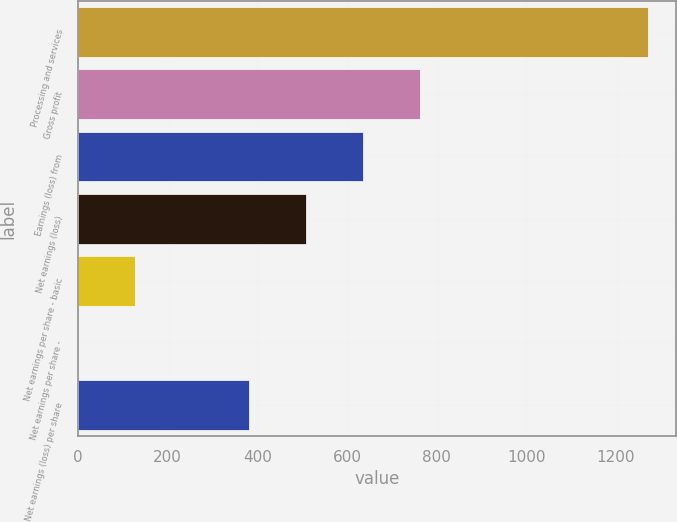Convert chart. <chart><loc_0><loc_0><loc_500><loc_500><bar_chart><fcel>Processing and services<fcel>Gross profit<fcel>Earnings (loss) from<fcel>Net earnings (loss)<fcel>Net earnings per share - basic<fcel>Net earnings per share -<fcel>Net earnings (loss) per share<nl><fcel>1271<fcel>762.71<fcel>635.63<fcel>508.55<fcel>127.31<fcel>0.23<fcel>381.47<nl></chart> 